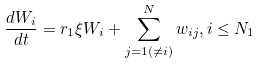<formula> <loc_0><loc_0><loc_500><loc_500>\frac { d W _ { i } } { d t } = r _ { 1 } \xi W _ { i } + \sum _ { j = 1 ( \neq i ) } ^ { N } w _ { i j } , i \leq N _ { 1 }</formula> 